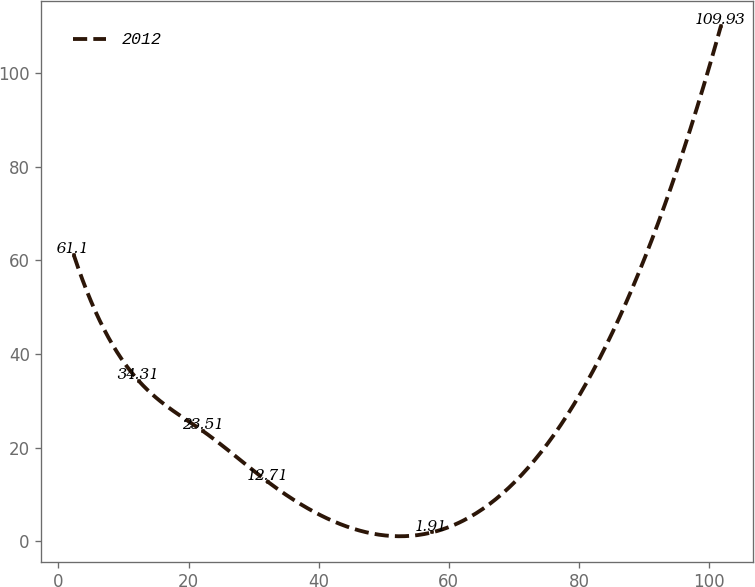Convert chart to OTSL. <chart><loc_0><loc_0><loc_500><loc_500><line_chart><ecel><fcel>2012<nl><fcel>2.38<fcel>61.1<nl><fcel>12.32<fcel>34.31<nl><fcel>22.26<fcel>23.51<nl><fcel>32.2<fcel>12.71<nl><fcel>57.35<fcel>1.91<nl><fcel>101.78<fcel>109.93<nl></chart> 